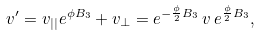<formula> <loc_0><loc_0><loc_500><loc_500>v ^ { \prime } = v _ { | | } e ^ { \phi B _ { 3 } } + v _ { \perp } = e ^ { - \frac { \phi } { 2 } B _ { 3 } } \, v \, e ^ { \frac { \phi } { 2 } B _ { 3 } } ,</formula> 